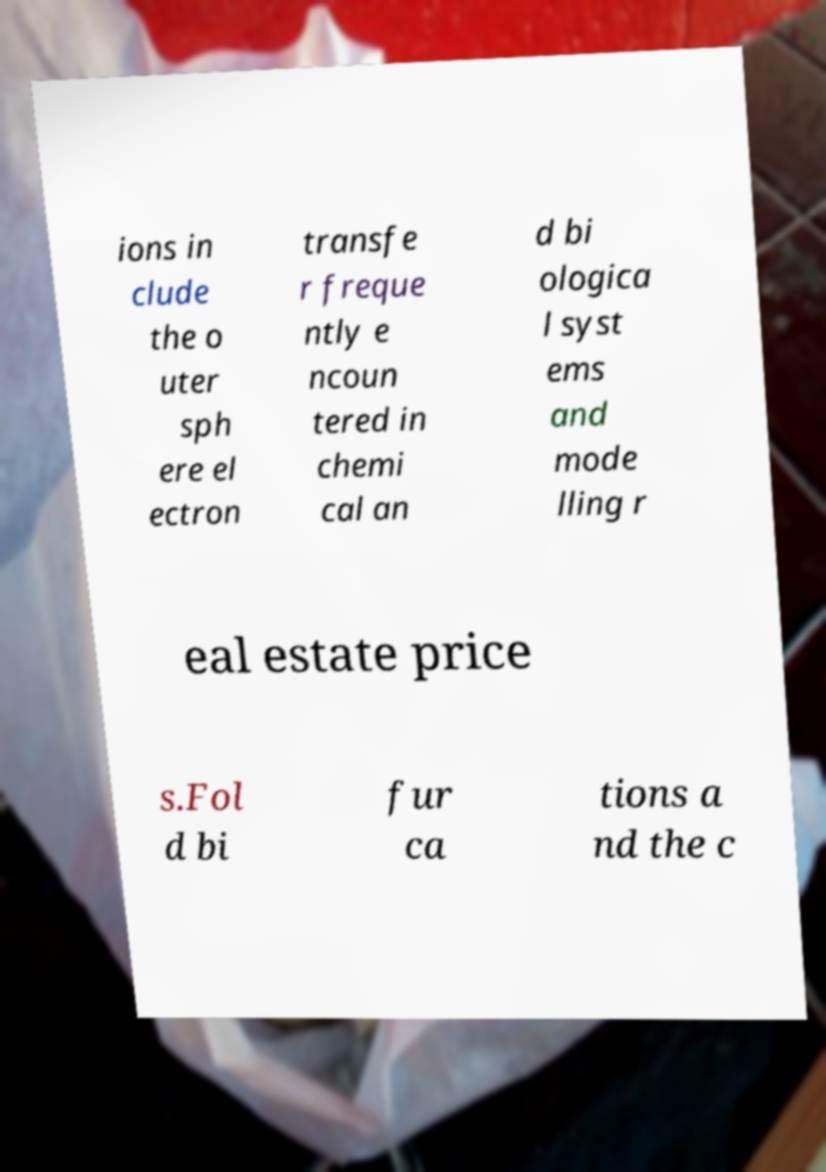Can you accurately transcribe the text from the provided image for me? ions in clude the o uter sph ere el ectron transfe r freque ntly e ncoun tered in chemi cal an d bi ologica l syst ems and mode lling r eal estate price s.Fol d bi fur ca tions a nd the c 